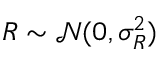Convert formula to latex. <formula><loc_0><loc_0><loc_500><loc_500>R \sim \mathcal { N } ( 0 , \sigma _ { R } ^ { 2 } )</formula> 